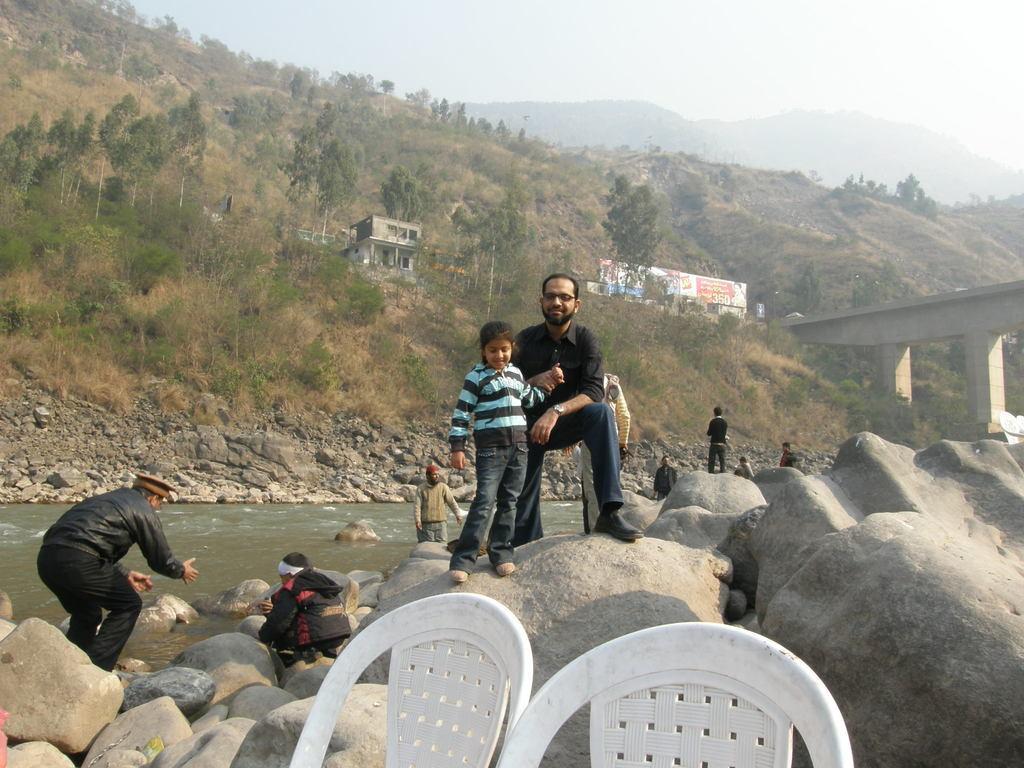How would you summarize this image in a sentence or two? In this picture we can see chairs, at the back of these chairs we can see stones, people, water, here we can see a bridge, chair, building, trees, banners and some objects and in the background we can see mountains, sky with clouds. 